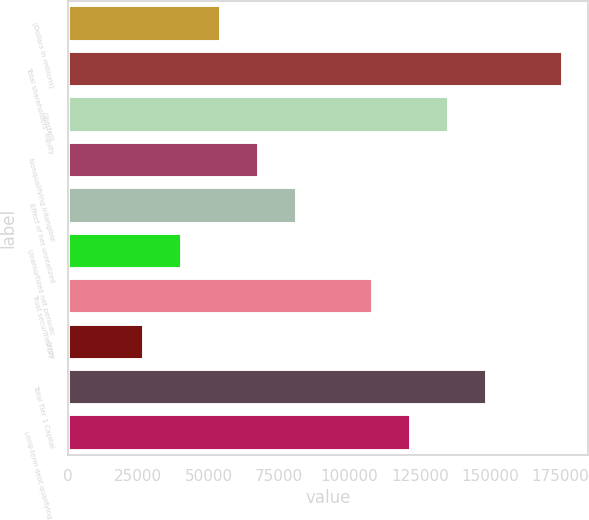<chart> <loc_0><loc_0><loc_500><loc_500><bar_chart><fcel>(Dollars in millions)<fcel>Total shareholders' equity<fcel>Goodwill<fcel>Nonqualifying intangible<fcel>Effect of net unrealized<fcel>Unamortized net periodic<fcel>Trust securities (2)<fcel>Other<fcel>Total Tier 1 Capital<fcel>Long-term debt qualifying as<nl><fcel>54230.6<fcel>175793<fcel>135272<fcel>67737.5<fcel>81244.4<fcel>40723.7<fcel>108258<fcel>27216.8<fcel>148779<fcel>121765<nl></chart> 